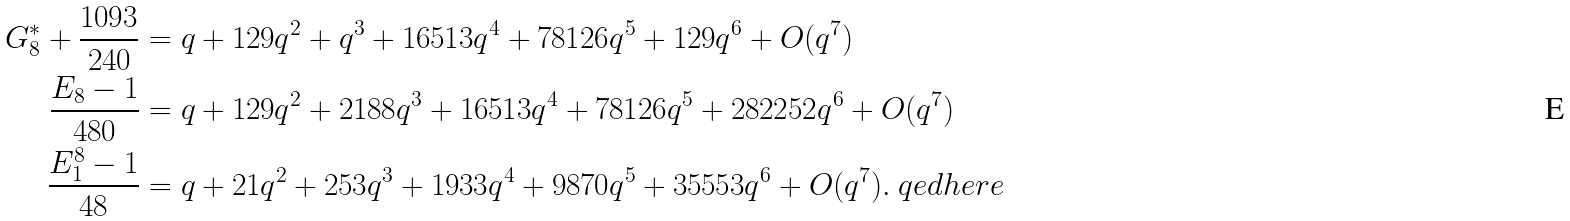<formula> <loc_0><loc_0><loc_500><loc_500>G _ { 8 } ^ { * } + \frac { 1 0 9 3 } { 2 4 0 } & = q + 1 2 9 q ^ { 2 } + q ^ { 3 } + 1 6 5 1 3 q ^ { 4 } + 7 8 1 2 6 q ^ { 5 } + 1 2 9 q ^ { 6 } + O ( q ^ { 7 } ) \\ \frac { E _ { 8 } - 1 } { 4 8 0 } & = q + 1 2 9 q ^ { 2 } + 2 1 8 8 q ^ { 3 } + 1 6 5 1 3 q ^ { 4 } + 7 8 1 2 6 q ^ { 5 } + 2 8 2 2 5 2 q ^ { 6 } + O ( q ^ { 7 } ) \\ \frac { E _ { 1 } ^ { 8 } - 1 } { 4 8 } & = q + 2 1 q ^ { 2 } + 2 5 3 q ^ { 3 } + 1 9 3 3 q ^ { 4 } + 9 8 7 0 q ^ { 5 } + 3 5 5 5 3 q ^ { 6 } + O ( q ^ { 7 } ) . \ q e d h e r e</formula> 